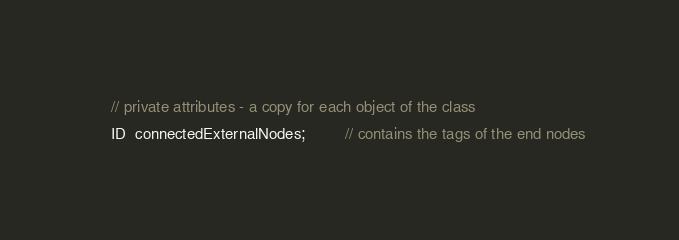<code> <loc_0><loc_0><loc_500><loc_500><_C_>    // private attributes - a copy for each object of the class
    ID  connectedExternalNodes;         // contains the tags of the end nodes</code> 